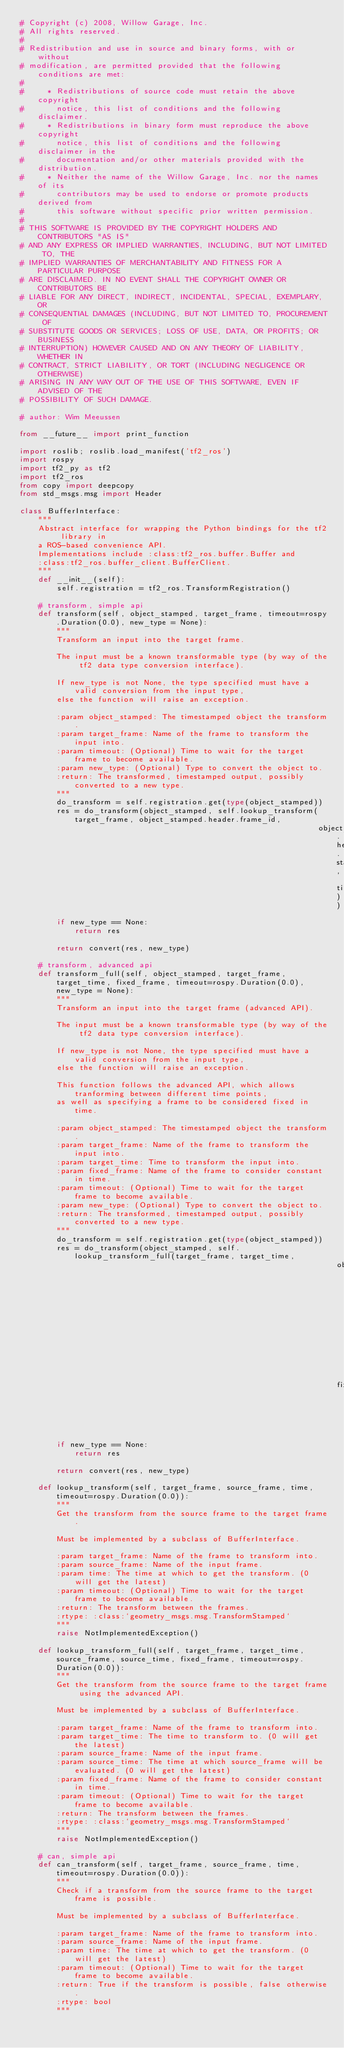Convert code to text. <code><loc_0><loc_0><loc_500><loc_500><_Python_># Copyright (c) 2008, Willow Garage, Inc.
# All rights reserved.
# 
# Redistribution and use in source and binary forms, with or without
# modification, are permitted provided that the following conditions are met:
# 
#     * Redistributions of source code must retain the above copyright
#       notice, this list of conditions and the following disclaimer.
#     * Redistributions in binary form must reproduce the above copyright
#       notice, this list of conditions and the following disclaimer in the
#       documentation and/or other materials provided with the distribution.
#     * Neither the name of the Willow Garage, Inc. nor the names of its
#       contributors may be used to endorse or promote products derived from
#       this software without specific prior written permission.
# 
# THIS SOFTWARE IS PROVIDED BY THE COPYRIGHT HOLDERS AND CONTRIBUTORS "AS IS"
# AND ANY EXPRESS OR IMPLIED WARRANTIES, INCLUDING, BUT NOT LIMITED TO, THE
# IMPLIED WARRANTIES OF MERCHANTABILITY AND FITNESS FOR A PARTICULAR PURPOSE
# ARE DISCLAIMED. IN NO EVENT SHALL THE COPYRIGHT OWNER OR CONTRIBUTORS BE
# LIABLE FOR ANY DIRECT, INDIRECT, INCIDENTAL, SPECIAL, EXEMPLARY, OR
# CONSEQUENTIAL DAMAGES (INCLUDING, BUT NOT LIMITED TO, PROCUREMENT OF
# SUBSTITUTE GOODS OR SERVICES; LOSS OF USE, DATA, OR PROFITS; OR BUSINESS
# INTERRUPTION) HOWEVER CAUSED AND ON ANY THEORY OF LIABILITY, WHETHER IN
# CONTRACT, STRICT LIABILITY, OR TORT (INCLUDING NEGLIGENCE OR OTHERWISE)
# ARISING IN ANY WAY OUT OF THE USE OF THIS SOFTWARE, EVEN IF ADVISED OF THE
# POSSIBILITY OF SUCH DAMAGE.

# author: Wim Meeussen

from __future__ import print_function

import roslib; roslib.load_manifest('tf2_ros')
import rospy
import tf2_py as tf2
import tf2_ros
from copy import deepcopy
from std_msgs.msg import Header

class BufferInterface:
    """
    Abstract interface for wrapping the Python bindings for the tf2 library in
    a ROS-based convenience API.
    Implementations include :class:tf2_ros.buffer.Buffer and
    :class:tf2_ros.buffer_client.BufferClient.
    """
    def __init__(self):
        self.registration = tf2_ros.TransformRegistration()

    # transform, simple api
    def transform(self, object_stamped, target_frame, timeout=rospy.Duration(0.0), new_type = None):
        """
        Transform an input into the target frame.

        The input must be a known transformable type (by way of the tf2 data type conversion interface).

        If new_type is not None, the type specified must have a valid conversion from the input type,
        else the function will raise an exception.

        :param object_stamped: The timestamped object the transform.
        :param target_frame: Name of the frame to transform the input into.
        :param timeout: (Optional) Time to wait for the target frame to become available.
        :param new_type: (Optional) Type to convert the object to.
        :return: The transformed, timestamped output, possibly converted to a new type.
        """
        do_transform = self.registration.get(type(object_stamped))
        res = do_transform(object_stamped, self.lookup_transform(target_frame, object_stamped.header.frame_id,
                                                                 object_stamped.header.stamp, timeout))
        if new_type == None:
            return res

        return convert(res, new_type)

    # transform, advanced api
    def transform_full(self, object_stamped, target_frame, target_time, fixed_frame, timeout=rospy.Duration(0.0), new_type = None):
        """
        Transform an input into the target frame (advanced API).

        The input must be a known transformable type (by way of the tf2 data type conversion interface).

        If new_type is not None, the type specified must have a valid conversion from the input type,
        else the function will raise an exception.

        This function follows the advanced API, which allows tranforming between different time points,
        as well as specifying a frame to be considered fixed in time.

        :param object_stamped: The timestamped object the transform.
        :param target_frame: Name of the frame to transform the input into.
        :param target_time: Time to transform the input into.
        :param fixed_frame: Name of the frame to consider constant in time.
        :param timeout: (Optional) Time to wait for the target frame to become available.
        :param new_type: (Optional) Type to convert the object to.
        :return: The transformed, timestamped output, possibly converted to a new type.
        """
        do_transform = self.registration.get(type(object_stamped))
        res = do_transform(object_stamped, self.lookup_transform_full(target_frame, target_time,
                                                                     object_stamped.header.frame_id, object_stamped.header.stamp, 
                                                                     fixed_frame, timeout))
        if new_type == None:
            return res

        return convert(res, new_type)

    def lookup_transform(self, target_frame, source_frame, time, timeout=rospy.Duration(0.0)):
        """
        Get the transform from the source frame to the target frame.

        Must be implemented by a subclass of BufferInterface.

        :param target_frame: Name of the frame to transform into.
        :param source_frame: Name of the input frame.
        :param time: The time at which to get the transform. (0 will get the latest) 
        :param timeout: (Optional) Time to wait for the target frame to become available.
        :return: The transform between the frames.
        :rtype: :class:`geometry_msgs.msg.TransformStamped`
        """
        raise NotImplementedException()

    def lookup_transform_full(self, target_frame, target_time, source_frame, source_time, fixed_frame, timeout=rospy.Duration(0.0)):
        """
        Get the transform from the source frame to the target frame using the advanced API.

        Must be implemented by a subclass of BufferInterface.

        :param target_frame: Name of the frame to transform into.
        :param target_time: The time to transform to. (0 will get the latest) 
        :param source_frame: Name of the input frame.
        :param source_time: The time at which source_frame will be evaluated. (0 will get the latest) 
        :param fixed_frame: Name of the frame to consider constant in time.
        :param timeout: (Optional) Time to wait for the target frame to become available.
        :return: The transform between the frames.
        :rtype: :class:`geometry_msgs.msg.TransformStamped`
        """
        raise NotImplementedException()        

    # can, simple api
    def can_transform(self, target_frame, source_frame, time, timeout=rospy.Duration(0.0)):
        """
        Check if a transform from the source frame to the target frame is possible.

        Must be implemented by a subclass of BufferInterface.

        :param target_frame: Name of the frame to transform into.
        :param source_frame: Name of the input frame.
        :param time: The time at which to get the transform. (0 will get the latest) 
        :param timeout: (Optional) Time to wait for the target frame to become available.
        :return: True if the transform is possible, false otherwise.
        :rtype: bool
        """</code> 